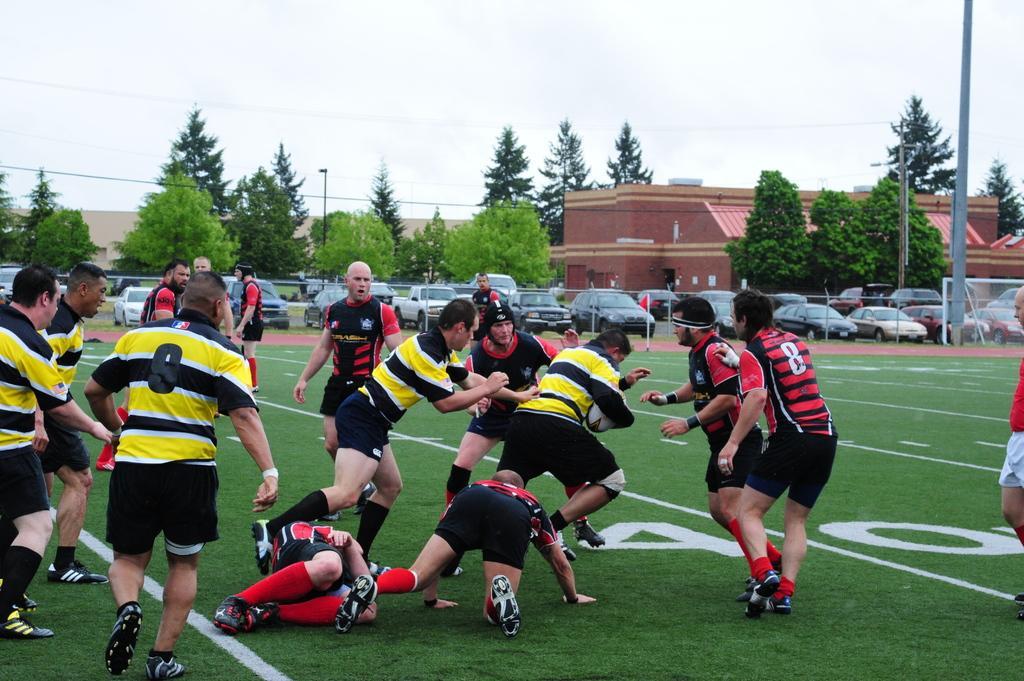Can you describe this image briefly? In this image we can see a group of people playing the rugby game on the ground. Here we can see a man holding the rugby ball in his hand. Here we can see a pole on the right side. In the background, we can see the houses, trees, cars. Here we can see an electric pole and electric wires. Here we can see the metal fence. 